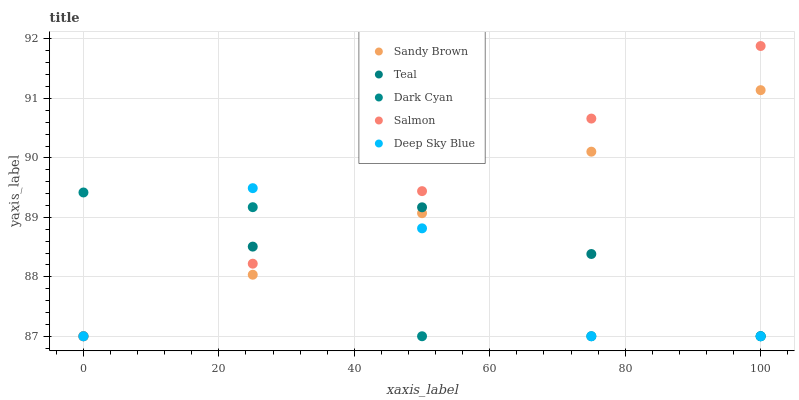Does Dark Cyan have the minimum area under the curve?
Answer yes or no. Yes. Does Salmon have the maximum area under the curve?
Answer yes or no. Yes. Does Sandy Brown have the minimum area under the curve?
Answer yes or no. No. Does Sandy Brown have the maximum area under the curve?
Answer yes or no. No. Is Salmon the smoothest?
Answer yes or no. Yes. Is Deep Sky Blue the roughest?
Answer yes or no. Yes. Is Sandy Brown the smoothest?
Answer yes or no. No. Is Sandy Brown the roughest?
Answer yes or no. No. Does Dark Cyan have the lowest value?
Answer yes or no. Yes. Does Salmon have the highest value?
Answer yes or no. Yes. Does Sandy Brown have the highest value?
Answer yes or no. No. Does Salmon intersect Sandy Brown?
Answer yes or no. Yes. Is Salmon less than Sandy Brown?
Answer yes or no. No. Is Salmon greater than Sandy Brown?
Answer yes or no. No. 